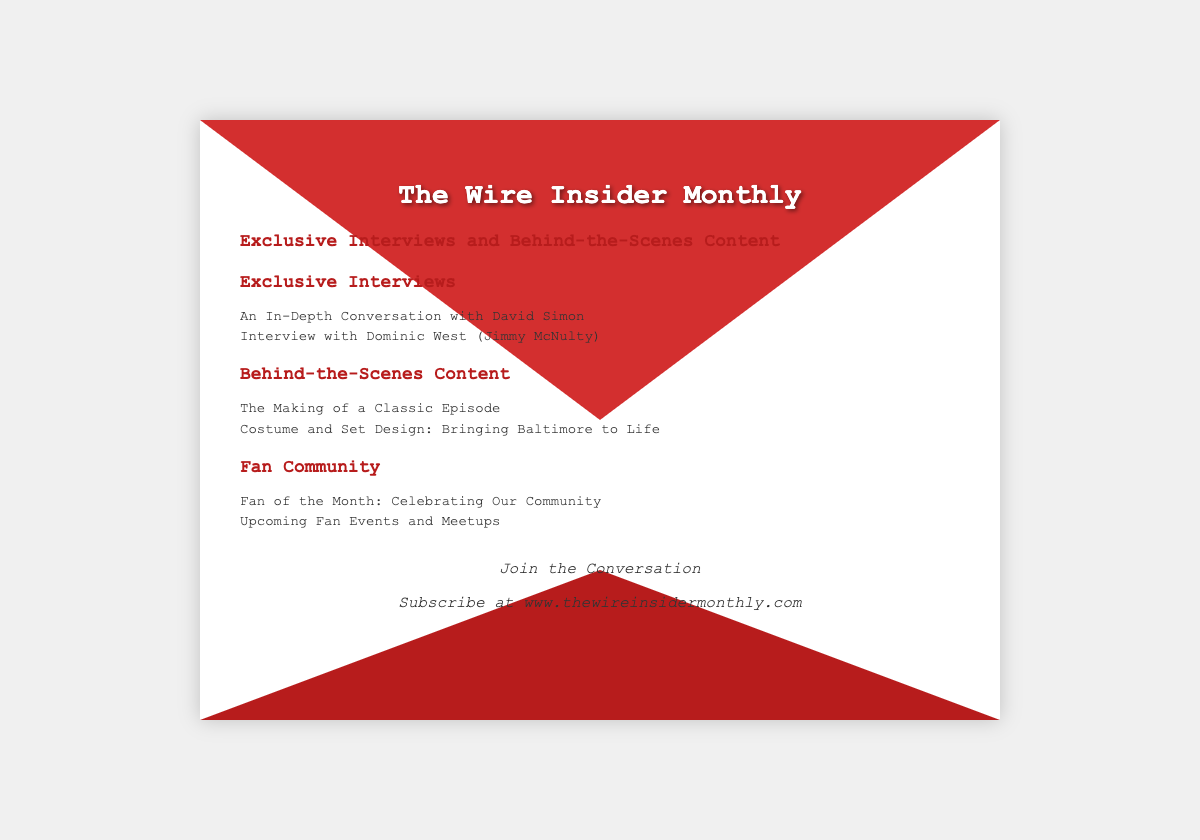What is the title of the newsletter? The title of the newsletter is "The Wire Insider Monthly," as stated at the top of the document.
Answer: The Wire Insider Monthly Who is interviewed in the newsletter? The newsletter includes interviews with David Simon and Dominic West (Jimmy McNulty).
Answer: David Simon; Dominic West What type of content is included besides interviews? The newsletter features behind-the-scenes content in addition to exclusive interviews.
Answer: Behind-the-Scenes Content What event is highlighted in the Fan Community section? The Fan Community section features "Fan of the Month" as a highlighted event.
Answer: Fan of the Month Where can subscribers join the conversation? Subscribers can join the conversation at "www.thewireinsidermonthly.com," as mentioned in the subscription section.
Answer: www.thewireinsidermonthly.com What is the primary theme of this newsletter? The primary theme of the newsletter is exclusive interviews and behind-the-scenes content related to "The Wire."
Answer: Exclusive Interviews and Behind-the-Scenes Content How many exclusive interviews are mentioned? There are two exclusive interviews mentioned in the newsletter: one with David Simon and one with Dominic West.
Answer: Two What kind of design aspects are discussed? The newsletter discusses costume and set design as aspects of bringing Baltimore to life in the behind-the-scenes content.
Answer: Costume and Set Design 